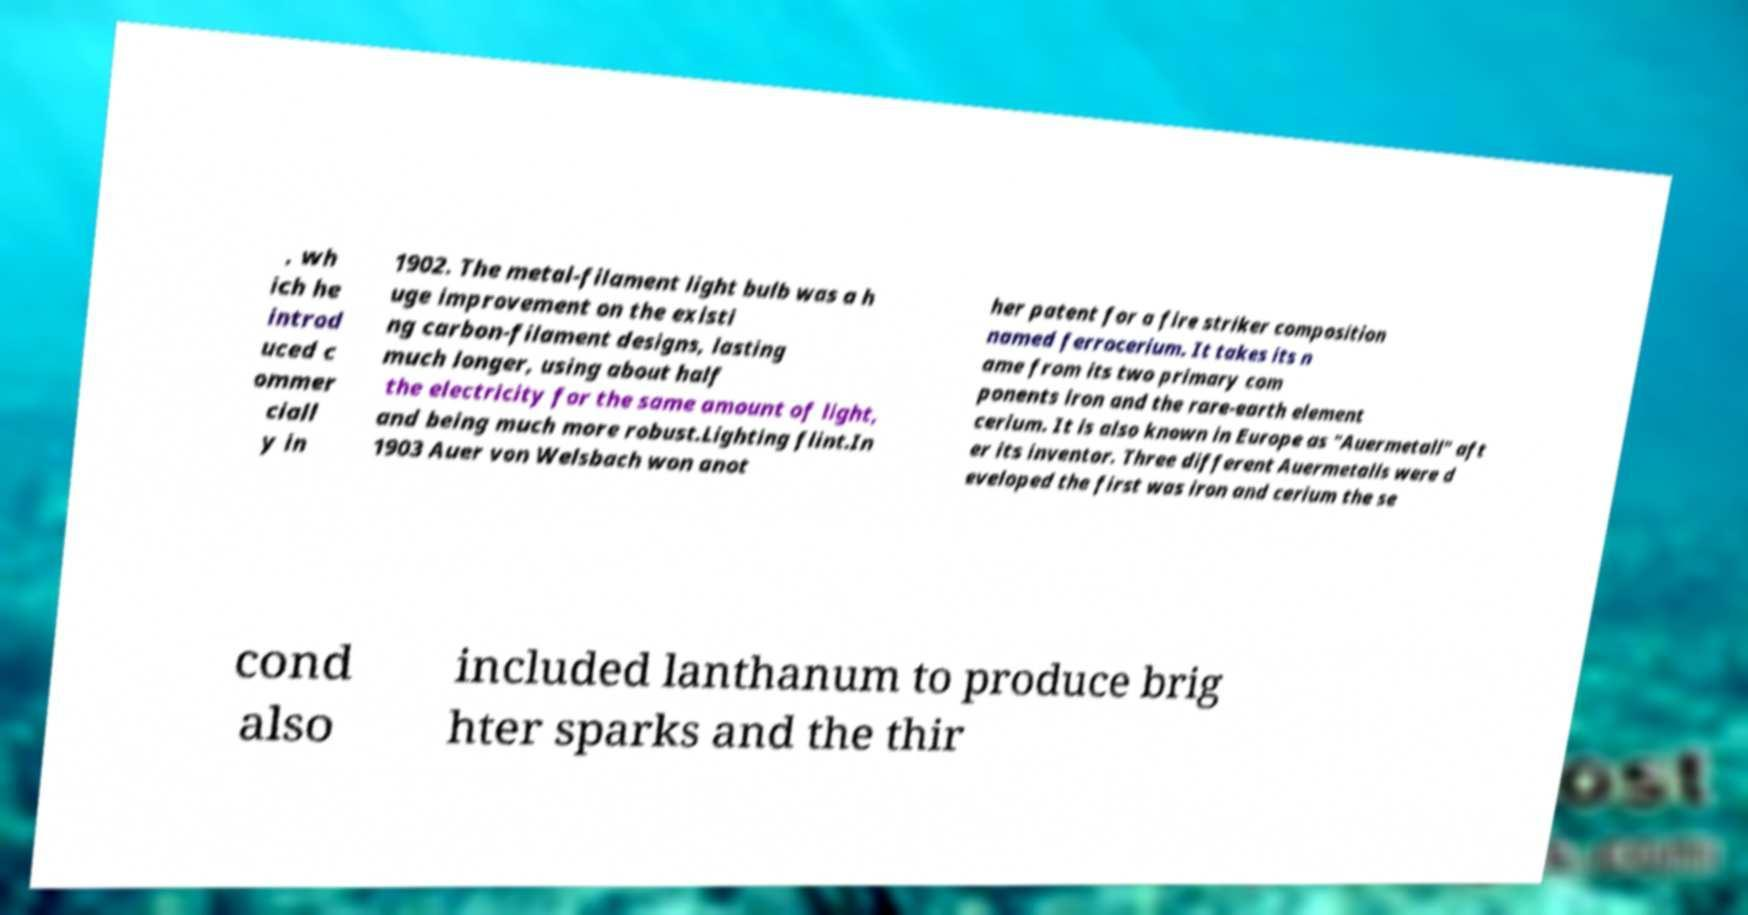I need the written content from this picture converted into text. Can you do that? , wh ich he introd uced c ommer ciall y in 1902. The metal-filament light bulb was a h uge improvement on the existi ng carbon-filament designs, lasting much longer, using about half the electricity for the same amount of light, and being much more robust.Lighting flint.In 1903 Auer von Welsbach won anot her patent for a fire striker composition named ferrocerium. It takes its n ame from its two primary com ponents iron and the rare-earth element cerium. It is also known in Europe as "Auermetall" aft er its inventor. Three different Auermetalls were d eveloped the first was iron and cerium the se cond also included lanthanum to produce brig hter sparks and the thir 